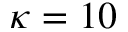Convert formula to latex. <formula><loc_0><loc_0><loc_500><loc_500>\kappa = 1 0</formula> 